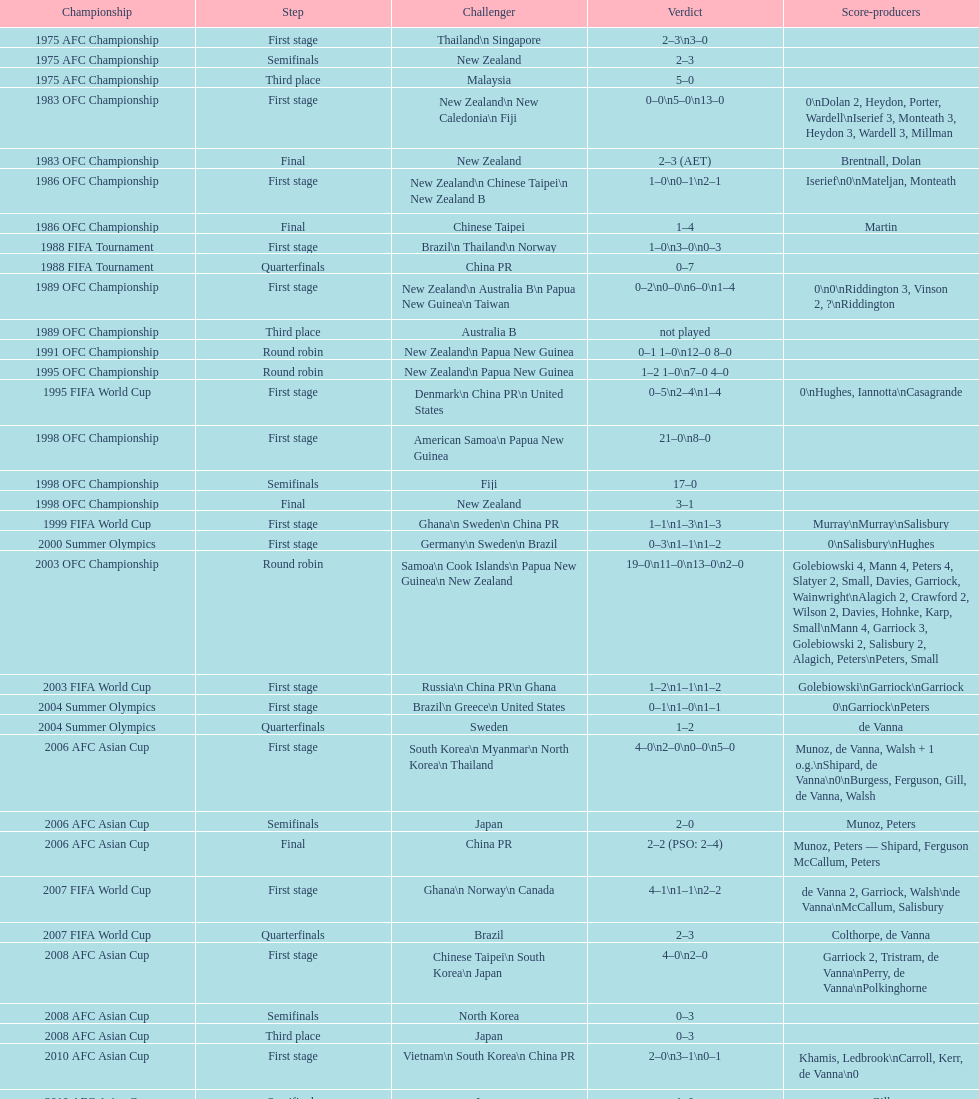Who was this team's next opponent after facing new zealand in the first stage of the 1986 ofc championship? Chinese Taipei. 